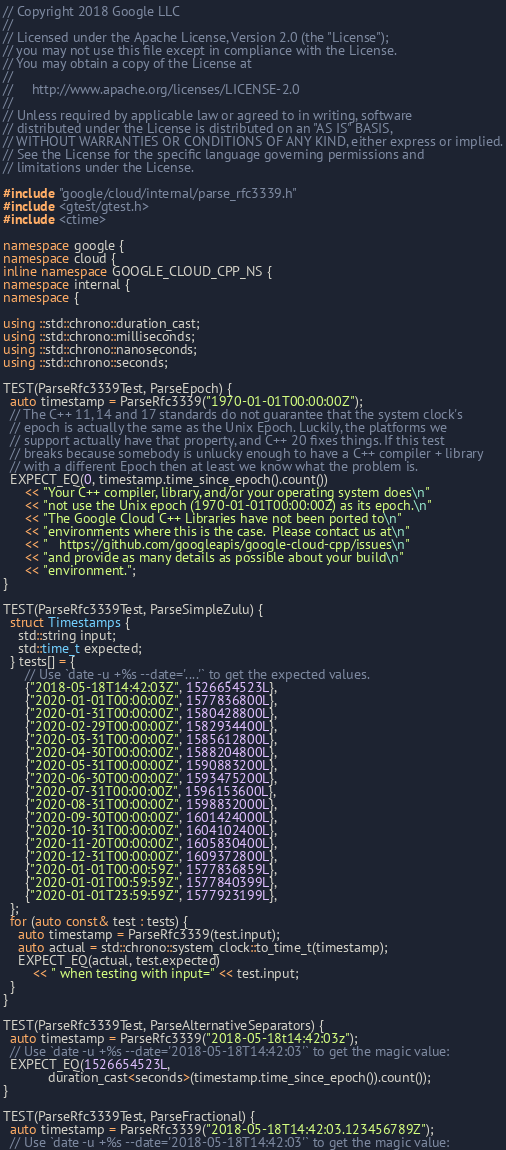<code> <loc_0><loc_0><loc_500><loc_500><_C++_>// Copyright 2018 Google LLC
//
// Licensed under the Apache License, Version 2.0 (the "License");
// you may not use this file except in compliance with the License.
// You may obtain a copy of the License at
//
//     http://www.apache.org/licenses/LICENSE-2.0
//
// Unless required by applicable law or agreed to in writing, software
// distributed under the License is distributed on an "AS IS" BASIS,
// WITHOUT WARRANTIES OR CONDITIONS OF ANY KIND, either express or implied.
// See the License for the specific language governing permissions and
// limitations under the License.

#include "google/cloud/internal/parse_rfc3339.h"
#include <gtest/gtest.h>
#include <ctime>

namespace google {
namespace cloud {
inline namespace GOOGLE_CLOUD_CPP_NS {
namespace internal {
namespace {

using ::std::chrono::duration_cast;
using ::std::chrono::milliseconds;
using ::std::chrono::nanoseconds;
using ::std::chrono::seconds;

TEST(ParseRfc3339Test, ParseEpoch) {
  auto timestamp = ParseRfc3339("1970-01-01T00:00:00Z");
  // The C++ 11, 14 and 17 standards do not guarantee that the system clock's
  // epoch is actually the same as the Unix Epoch. Luckily, the platforms we
  // support actually have that property, and C++ 20 fixes things. If this test
  // breaks because somebody is unlucky enough to have a C++ compiler + library
  // with a different Epoch then at least we know what the problem is.
  EXPECT_EQ(0, timestamp.time_since_epoch().count())
      << "Your C++ compiler, library, and/or your operating system does\n"
      << "not use the Unix epoch (1970-01-01T00:00:00Z) as its epoch.\n"
      << "The Google Cloud C++ Libraries have not been ported to\n"
      << "environments where this is the case.  Please contact us at\n"
      << "   https://github.com/googleapis/google-cloud-cpp/issues\n"
      << "and provide as many details as possible about your build\n"
      << "environment.";
}

TEST(ParseRfc3339Test, ParseSimpleZulu) {
  struct Timestamps {
    std::string input;
    std::time_t expected;
  } tests[] = {
      // Use `date -u +%s --date='....'` to get the expected values.
      {"2018-05-18T14:42:03Z", 1526654523L},
      {"2020-01-01T00:00:00Z", 1577836800L},
      {"2020-01-31T00:00:00Z", 1580428800L},
      {"2020-02-29T00:00:00Z", 1582934400L},
      {"2020-03-31T00:00:00Z", 1585612800L},
      {"2020-04-30T00:00:00Z", 1588204800L},
      {"2020-05-31T00:00:00Z", 1590883200L},
      {"2020-06-30T00:00:00Z", 1593475200L},
      {"2020-07-31T00:00:00Z", 1596153600L},
      {"2020-08-31T00:00:00Z", 1598832000L},
      {"2020-09-30T00:00:00Z", 1601424000L},
      {"2020-10-31T00:00:00Z", 1604102400L},
      {"2020-11-20T00:00:00Z", 1605830400L},
      {"2020-12-31T00:00:00Z", 1609372800L},
      {"2020-01-01T00:00:59Z", 1577836859L},
      {"2020-01-01T00:59:59Z", 1577840399L},
      {"2020-01-01T23:59:59Z", 1577923199L},
  };
  for (auto const& test : tests) {
    auto timestamp = ParseRfc3339(test.input);
    auto actual = std::chrono::system_clock::to_time_t(timestamp);
    EXPECT_EQ(actual, test.expected)
        << " when testing with input=" << test.input;
  }
}

TEST(ParseRfc3339Test, ParseAlternativeSeparators) {
  auto timestamp = ParseRfc3339("2018-05-18t14:42:03z");
  // Use `date -u +%s --date='2018-05-18T14:42:03'` to get the magic value:
  EXPECT_EQ(1526654523L,
            duration_cast<seconds>(timestamp.time_since_epoch()).count());
}

TEST(ParseRfc3339Test, ParseFractional) {
  auto timestamp = ParseRfc3339("2018-05-18T14:42:03.123456789Z");
  // Use `date -u +%s --date='2018-05-18T14:42:03'` to get the magic value:</code> 